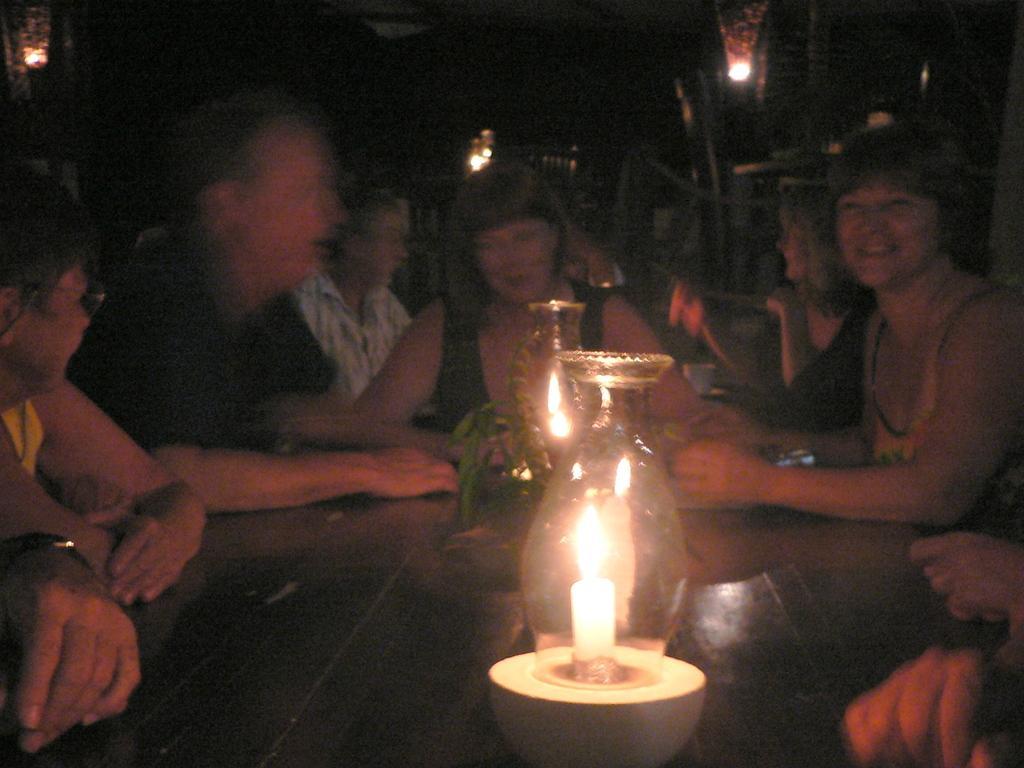Please provide a concise description of this image. In this picture we can see a group of people. In front of the people, there is a table and on the table, there are glass chimneys with candles and there is a houseplant. Behind the people, there are lights, some objects and a dark background. 